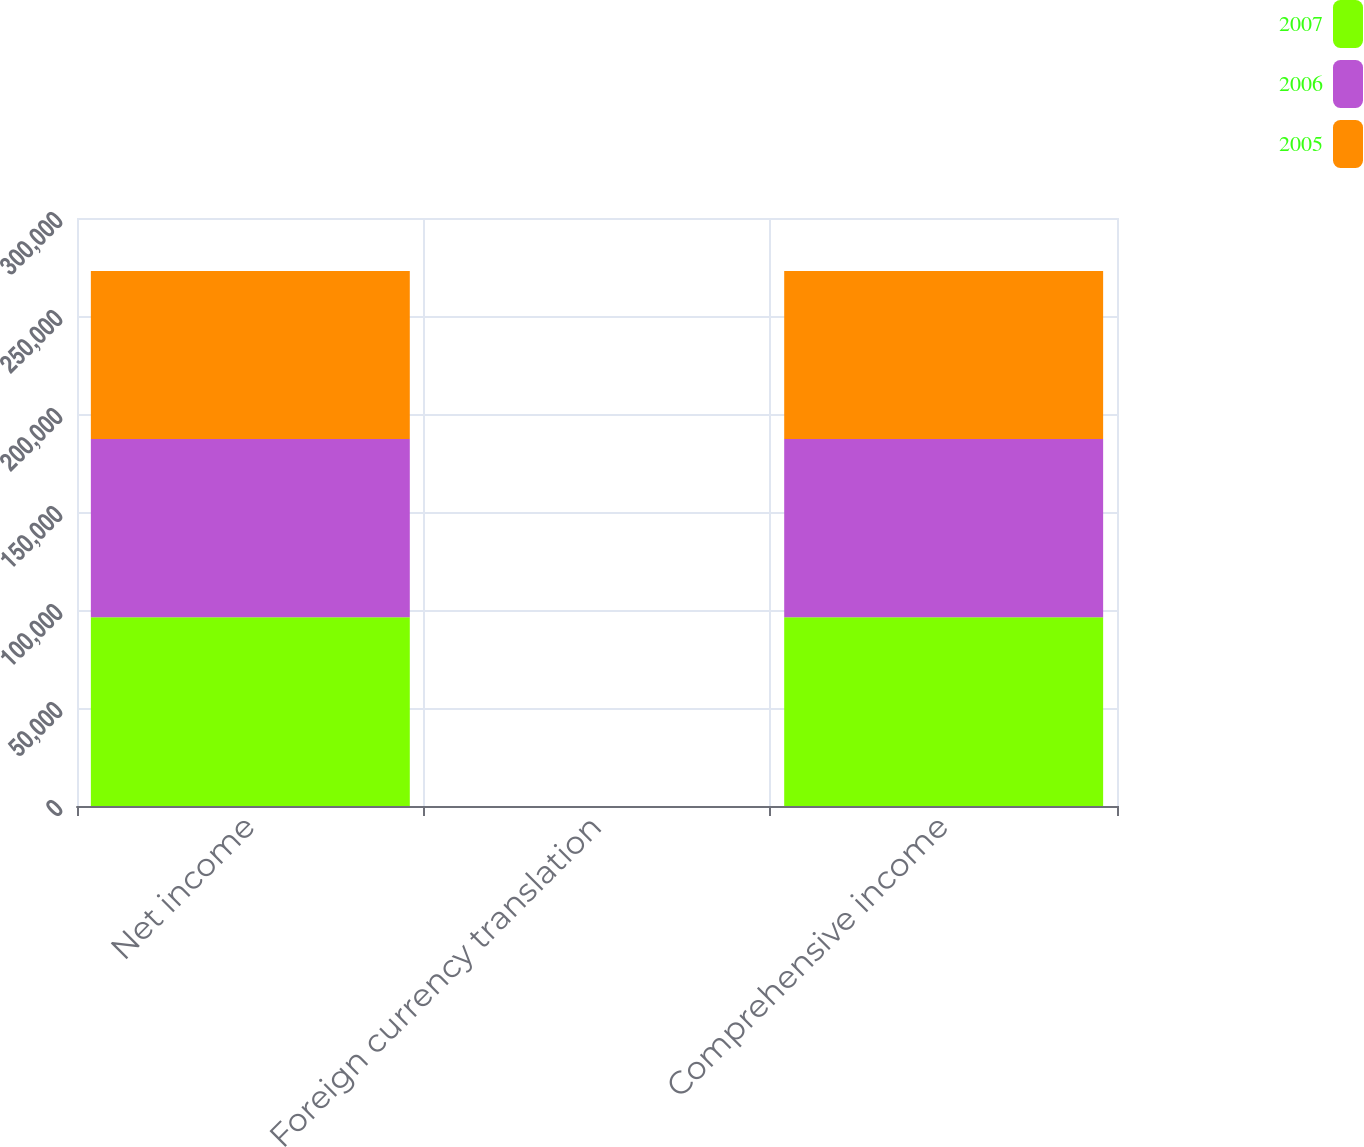<chart> <loc_0><loc_0><loc_500><loc_500><stacked_bar_chart><ecel><fcel>Net income<fcel>Foreign currency translation<fcel>Comprehensive income<nl><fcel>2007<fcel>96241<fcel>22<fcel>96263<nl><fcel>2006<fcel>91008<fcel>11<fcel>90997<nl><fcel>2005<fcel>85669<fcel>11<fcel>85658<nl></chart> 